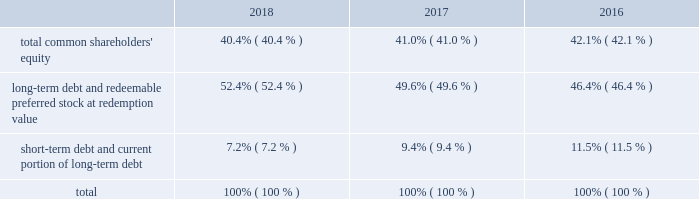Allows us to repurchase shares at times when we may otherwise be prevented from doing so under insider trading laws or because of self-imposed trading blackout periods .
Subject to applicable regulations , we may elect to amend or cancel this repurchase program or the share repurchase parameters at our discretion .
As of december 31 , 2018 , we have repurchased an aggregate of 4510000 shares of common stock under this program .
Credit facilities and short-term debt we have an unsecured revolving credit facility of $ 2.25 billion that expires in june 2023 .
In march 2018 , awcc and its lenders amended and restated the credit agreement with respect to awcc 2019s revolving credit facility to increase the maximum commitments under the facility from $ 1.75 billion to $ 2.25 billion , and to extend the expiration date of the facility from june 2020 to march 2023 .
All other terms , conditions and covenants with respect to the existing facility remained unchanged .
Subject to satisfying certain conditions , the credit agreement also permits awcc to increase the maximum commitment under the facility by up to an aggregate of $ 500 million , and to request extensions of its expiration date for up to two , one-year periods .
Interest rates on advances under the facility are based on a credit spread to the libor rate or base rate in accordance with moody investors service 2019s and standard & poor 2019s financial services 2019 then applicable credit rating on awcc 2019s senior unsecured , non-credit enhanced debt .
The facility is used principally to support awcc 2019s commercial paper program and to provide up to $ 150 million in letters of credit .
Indebtedness under the facility is considered 201cdebt 201d for purposes of a support agreement between the company and awcc , which serves as a functional equivalent of a guarantee by the company of awcc 2019s payment obligations under the credit facility .
Awcc also has an outstanding commercial paper program that is backed by the revolving credit facility , the maximum aggregate outstanding amount of which was increased in march 2018 , from $ 1.60 billion to $ 2.10 billion .
The table provides the aggregate credit facility commitments , letter of credit sub-limit under the revolving credit facility and commercial paper limit , as well as the available capacity for each as of december 31 , 2018 and 2017 : credit facility commitment available credit facility capacity letter of credit sublimit available letter of credit capacity commercial paper limit available commercial capacity ( in millions ) december 31 , 2018 .
$ 2262 $ 2177 $ 150 $ 69 $ 2100 $ 1146 december 31 , 2017 .
1762 1673 150 66 1600 695 the weighted average interest rate on awcc short-term borrowings for the years ended december 31 , 2018 and 2017 was approximately 2.28% ( 2.28 % ) and 1.24% ( 1.24 % ) , respectively .
Capital structure the table provides the percentage of our capitalization represented by the components of our capital structure as of december 31: .

For the awcc commercial paper program that is backed by the revolving credit facility , what was the change in billions of the maximum aggregate outstanding amount from march 2018 , to december 2018? 
Computations: (2.10 - 1.60)
Answer: 0.5. 